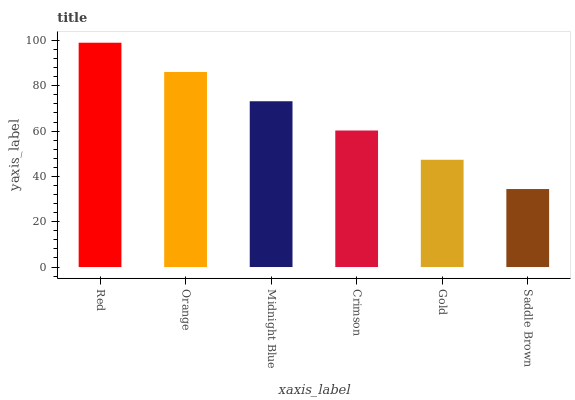Is Saddle Brown the minimum?
Answer yes or no. Yes. Is Red the maximum?
Answer yes or no. Yes. Is Orange the minimum?
Answer yes or no. No. Is Orange the maximum?
Answer yes or no. No. Is Red greater than Orange?
Answer yes or no. Yes. Is Orange less than Red?
Answer yes or no. Yes. Is Orange greater than Red?
Answer yes or no. No. Is Red less than Orange?
Answer yes or no. No. Is Midnight Blue the high median?
Answer yes or no. Yes. Is Crimson the low median?
Answer yes or no. Yes. Is Red the high median?
Answer yes or no. No. Is Saddle Brown the low median?
Answer yes or no. No. 